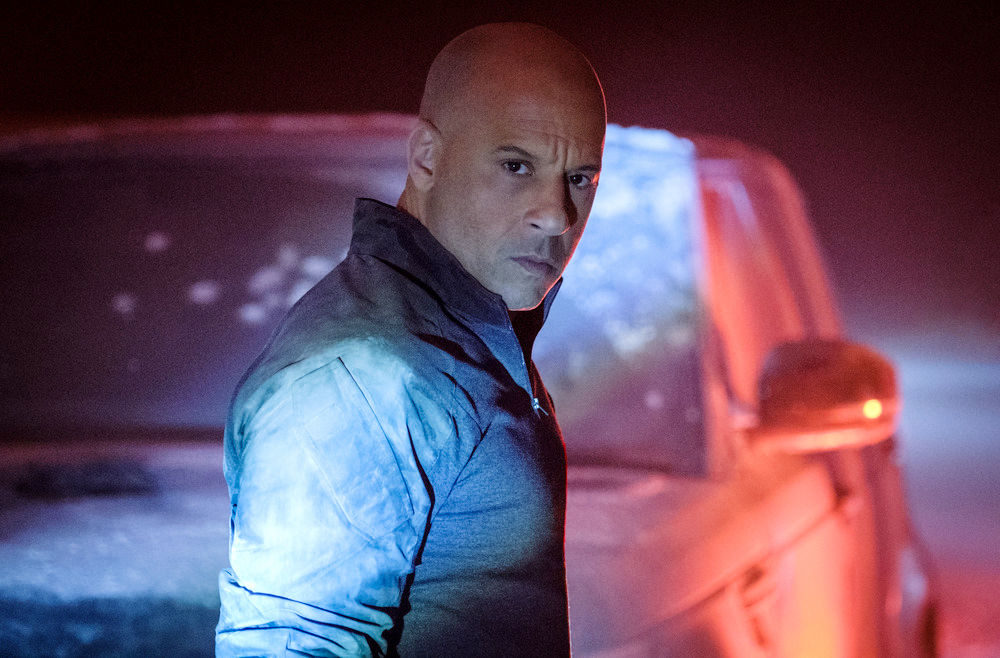What is the man thinking just before he sets off on his mission? The man looks over his shoulder, reflecting on the weight of his mission. Perhaps he thinks about the loved ones he's left behind, the risks he is about to take, and the justice he seeks to deliver. His thoughts are a blend of resolve and caution, knowing that every move counts. The fog around him symbolizes the uncertainties ahead, but his sharpened gaze reveals a mind fully prepared for the challenges he is about to face. 